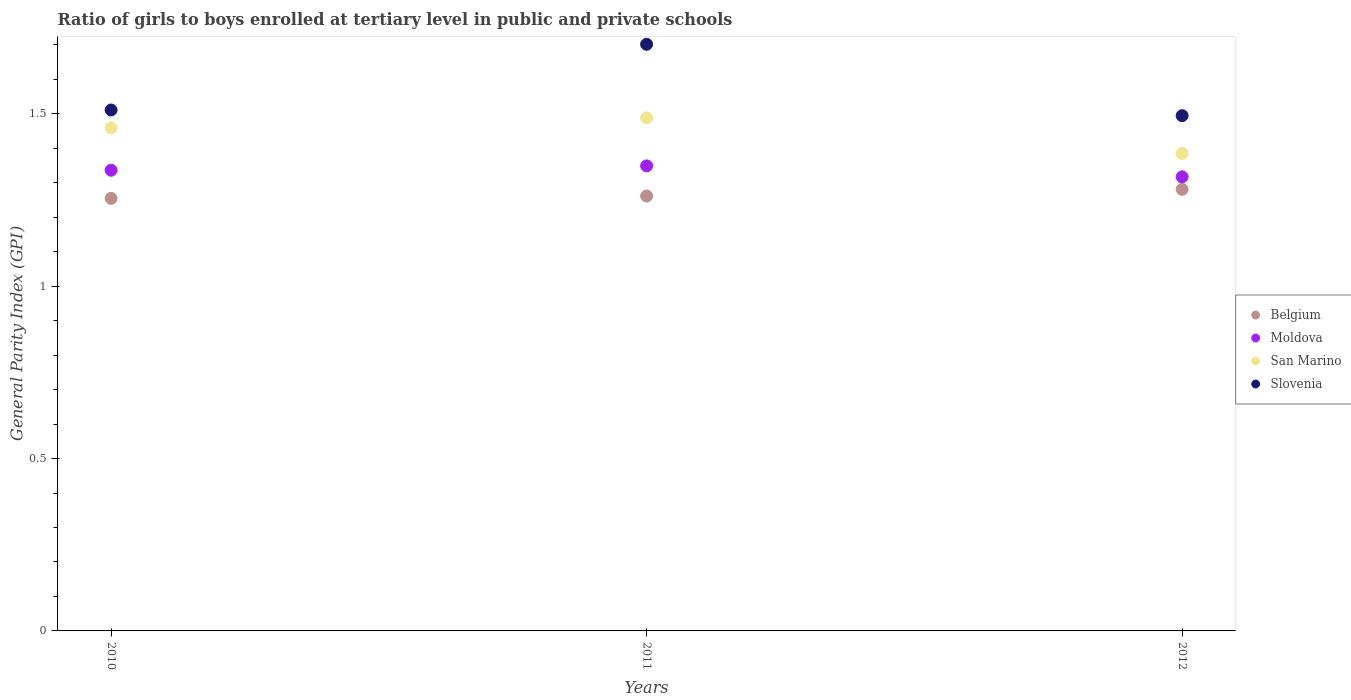How many different coloured dotlines are there?
Offer a very short reply. 4. What is the general parity index in Belgium in 2010?
Your answer should be very brief. 1.25. Across all years, what is the maximum general parity index in Belgium?
Make the answer very short. 1.28. Across all years, what is the minimum general parity index in San Marino?
Offer a very short reply. 1.38. In which year was the general parity index in Belgium maximum?
Provide a succinct answer. 2012. What is the total general parity index in Slovenia in the graph?
Provide a short and direct response. 4.71. What is the difference between the general parity index in Slovenia in 2011 and that in 2012?
Give a very brief answer. 0.21. What is the difference between the general parity index in Moldova in 2011 and the general parity index in Slovenia in 2012?
Your answer should be very brief. -0.15. What is the average general parity index in Slovenia per year?
Make the answer very short. 1.57. In the year 2011, what is the difference between the general parity index in Slovenia and general parity index in Belgium?
Your answer should be very brief. 0.44. What is the ratio of the general parity index in San Marino in 2010 to that in 2011?
Keep it short and to the point. 0.98. Is the general parity index in Slovenia in 2010 less than that in 2012?
Make the answer very short. No. What is the difference between the highest and the second highest general parity index in Slovenia?
Offer a terse response. 0.19. What is the difference between the highest and the lowest general parity index in Moldova?
Make the answer very short. 0.03. In how many years, is the general parity index in Slovenia greater than the average general parity index in Slovenia taken over all years?
Provide a succinct answer. 1. Is the sum of the general parity index in Belgium in 2010 and 2011 greater than the maximum general parity index in Moldova across all years?
Ensure brevity in your answer.  Yes. Is it the case that in every year, the sum of the general parity index in Moldova and general parity index in Belgium  is greater than the sum of general parity index in Slovenia and general parity index in San Marino?
Your answer should be very brief. Yes. Is it the case that in every year, the sum of the general parity index in San Marino and general parity index in Belgium  is greater than the general parity index in Slovenia?
Ensure brevity in your answer.  Yes. Does the general parity index in San Marino monotonically increase over the years?
Make the answer very short. No. Does the graph contain grids?
Your answer should be compact. No. Where does the legend appear in the graph?
Provide a short and direct response. Center right. What is the title of the graph?
Offer a terse response. Ratio of girls to boys enrolled at tertiary level in public and private schools. Does "Lesotho" appear as one of the legend labels in the graph?
Keep it short and to the point. No. What is the label or title of the X-axis?
Give a very brief answer. Years. What is the label or title of the Y-axis?
Ensure brevity in your answer.  General Parity Index (GPI). What is the General Parity Index (GPI) in Belgium in 2010?
Your response must be concise. 1.25. What is the General Parity Index (GPI) of Moldova in 2010?
Provide a short and direct response. 1.34. What is the General Parity Index (GPI) of San Marino in 2010?
Your response must be concise. 1.46. What is the General Parity Index (GPI) in Slovenia in 2010?
Make the answer very short. 1.51. What is the General Parity Index (GPI) in Belgium in 2011?
Offer a very short reply. 1.26. What is the General Parity Index (GPI) of Moldova in 2011?
Your response must be concise. 1.35. What is the General Parity Index (GPI) in San Marino in 2011?
Your answer should be very brief. 1.49. What is the General Parity Index (GPI) of Slovenia in 2011?
Provide a succinct answer. 1.7. What is the General Parity Index (GPI) in Belgium in 2012?
Offer a very short reply. 1.28. What is the General Parity Index (GPI) in Moldova in 2012?
Give a very brief answer. 1.32. What is the General Parity Index (GPI) in San Marino in 2012?
Make the answer very short. 1.38. What is the General Parity Index (GPI) in Slovenia in 2012?
Make the answer very short. 1.49. Across all years, what is the maximum General Parity Index (GPI) of Belgium?
Provide a short and direct response. 1.28. Across all years, what is the maximum General Parity Index (GPI) in Moldova?
Give a very brief answer. 1.35. Across all years, what is the maximum General Parity Index (GPI) in San Marino?
Your response must be concise. 1.49. Across all years, what is the maximum General Parity Index (GPI) in Slovenia?
Provide a short and direct response. 1.7. Across all years, what is the minimum General Parity Index (GPI) of Belgium?
Your response must be concise. 1.25. Across all years, what is the minimum General Parity Index (GPI) of Moldova?
Offer a very short reply. 1.32. Across all years, what is the minimum General Parity Index (GPI) of San Marino?
Your response must be concise. 1.38. Across all years, what is the minimum General Parity Index (GPI) of Slovenia?
Offer a very short reply. 1.49. What is the total General Parity Index (GPI) in Belgium in the graph?
Ensure brevity in your answer.  3.8. What is the total General Parity Index (GPI) in Moldova in the graph?
Your answer should be very brief. 4. What is the total General Parity Index (GPI) of San Marino in the graph?
Provide a succinct answer. 4.33. What is the total General Parity Index (GPI) of Slovenia in the graph?
Provide a succinct answer. 4.71. What is the difference between the General Parity Index (GPI) in Belgium in 2010 and that in 2011?
Provide a succinct answer. -0.01. What is the difference between the General Parity Index (GPI) of Moldova in 2010 and that in 2011?
Your answer should be compact. -0.01. What is the difference between the General Parity Index (GPI) of San Marino in 2010 and that in 2011?
Ensure brevity in your answer.  -0.03. What is the difference between the General Parity Index (GPI) of Slovenia in 2010 and that in 2011?
Make the answer very short. -0.19. What is the difference between the General Parity Index (GPI) in Belgium in 2010 and that in 2012?
Keep it short and to the point. -0.03. What is the difference between the General Parity Index (GPI) in Moldova in 2010 and that in 2012?
Give a very brief answer. 0.02. What is the difference between the General Parity Index (GPI) in San Marino in 2010 and that in 2012?
Keep it short and to the point. 0.07. What is the difference between the General Parity Index (GPI) in Slovenia in 2010 and that in 2012?
Give a very brief answer. 0.02. What is the difference between the General Parity Index (GPI) in Belgium in 2011 and that in 2012?
Provide a succinct answer. -0.02. What is the difference between the General Parity Index (GPI) of Moldova in 2011 and that in 2012?
Keep it short and to the point. 0.03. What is the difference between the General Parity Index (GPI) of San Marino in 2011 and that in 2012?
Give a very brief answer. 0.1. What is the difference between the General Parity Index (GPI) of Slovenia in 2011 and that in 2012?
Keep it short and to the point. 0.21. What is the difference between the General Parity Index (GPI) in Belgium in 2010 and the General Parity Index (GPI) in Moldova in 2011?
Offer a terse response. -0.09. What is the difference between the General Parity Index (GPI) of Belgium in 2010 and the General Parity Index (GPI) of San Marino in 2011?
Ensure brevity in your answer.  -0.23. What is the difference between the General Parity Index (GPI) in Belgium in 2010 and the General Parity Index (GPI) in Slovenia in 2011?
Offer a terse response. -0.45. What is the difference between the General Parity Index (GPI) of Moldova in 2010 and the General Parity Index (GPI) of San Marino in 2011?
Keep it short and to the point. -0.15. What is the difference between the General Parity Index (GPI) of Moldova in 2010 and the General Parity Index (GPI) of Slovenia in 2011?
Offer a very short reply. -0.37. What is the difference between the General Parity Index (GPI) of San Marino in 2010 and the General Parity Index (GPI) of Slovenia in 2011?
Offer a terse response. -0.24. What is the difference between the General Parity Index (GPI) in Belgium in 2010 and the General Parity Index (GPI) in Moldova in 2012?
Ensure brevity in your answer.  -0.06. What is the difference between the General Parity Index (GPI) in Belgium in 2010 and the General Parity Index (GPI) in San Marino in 2012?
Offer a terse response. -0.13. What is the difference between the General Parity Index (GPI) of Belgium in 2010 and the General Parity Index (GPI) of Slovenia in 2012?
Ensure brevity in your answer.  -0.24. What is the difference between the General Parity Index (GPI) in Moldova in 2010 and the General Parity Index (GPI) in San Marino in 2012?
Provide a succinct answer. -0.05. What is the difference between the General Parity Index (GPI) in Moldova in 2010 and the General Parity Index (GPI) in Slovenia in 2012?
Provide a short and direct response. -0.16. What is the difference between the General Parity Index (GPI) in San Marino in 2010 and the General Parity Index (GPI) in Slovenia in 2012?
Make the answer very short. -0.04. What is the difference between the General Parity Index (GPI) of Belgium in 2011 and the General Parity Index (GPI) of Moldova in 2012?
Your answer should be very brief. -0.06. What is the difference between the General Parity Index (GPI) in Belgium in 2011 and the General Parity Index (GPI) in San Marino in 2012?
Make the answer very short. -0.12. What is the difference between the General Parity Index (GPI) in Belgium in 2011 and the General Parity Index (GPI) in Slovenia in 2012?
Your answer should be very brief. -0.23. What is the difference between the General Parity Index (GPI) in Moldova in 2011 and the General Parity Index (GPI) in San Marino in 2012?
Your answer should be compact. -0.04. What is the difference between the General Parity Index (GPI) of Moldova in 2011 and the General Parity Index (GPI) of Slovenia in 2012?
Keep it short and to the point. -0.15. What is the difference between the General Parity Index (GPI) in San Marino in 2011 and the General Parity Index (GPI) in Slovenia in 2012?
Your answer should be compact. -0.01. What is the average General Parity Index (GPI) of Belgium per year?
Provide a short and direct response. 1.27. What is the average General Parity Index (GPI) in Moldova per year?
Provide a succinct answer. 1.33. What is the average General Parity Index (GPI) of San Marino per year?
Give a very brief answer. 1.44. What is the average General Parity Index (GPI) of Slovenia per year?
Offer a very short reply. 1.57. In the year 2010, what is the difference between the General Parity Index (GPI) of Belgium and General Parity Index (GPI) of Moldova?
Your answer should be very brief. -0.08. In the year 2010, what is the difference between the General Parity Index (GPI) of Belgium and General Parity Index (GPI) of San Marino?
Make the answer very short. -0.2. In the year 2010, what is the difference between the General Parity Index (GPI) of Belgium and General Parity Index (GPI) of Slovenia?
Offer a very short reply. -0.26. In the year 2010, what is the difference between the General Parity Index (GPI) of Moldova and General Parity Index (GPI) of San Marino?
Offer a terse response. -0.12. In the year 2010, what is the difference between the General Parity Index (GPI) of Moldova and General Parity Index (GPI) of Slovenia?
Provide a succinct answer. -0.17. In the year 2010, what is the difference between the General Parity Index (GPI) of San Marino and General Parity Index (GPI) of Slovenia?
Offer a terse response. -0.05. In the year 2011, what is the difference between the General Parity Index (GPI) in Belgium and General Parity Index (GPI) in Moldova?
Your answer should be compact. -0.09. In the year 2011, what is the difference between the General Parity Index (GPI) of Belgium and General Parity Index (GPI) of San Marino?
Provide a succinct answer. -0.23. In the year 2011, what is the difference between the General Parity Index (GPI) of Belgium and General Parity Index (GPI) of Slovenia?
Your response must be concise. -0.44. In the year 2011, what is the difference between the General Parity Index (GPI) in Moldova and General Parity Index (GPI) in San Marino?
Keep it short and to the point. -0.14. In the year 2011, what is the difference between the General Parity Index (GPI) of Moldova and General Parity Index (GPI) of Slovenia?
Give a very brief answer. -0.35. In the year 2011, what is the difference between the General Parity Index (GPI) of San Marino and General Parity Index (GPI) of Slovenia?
Your answer should be compact. -0.21. In the year 2012, what is the difference between the General Parity Index (GPI) in Belgium and General Parity Index (GPI) in Moldova?
Ensure brevity in your answer.  -0.04. In the year 2012, what is the difference between the General Parity Index (GPI) in Belgium and General Parity Index (GPI) in San Marino?
Your answer should be compact. -0.1. In the year 2012, what is the difference between the General Parity Index (GPI) of Belgium and General Parity Index (GPI) of Slovenia?
Keep it short and to the point. -0.21. In the year 2012, what is the difference between the General Parity Index (GPI) of Moldova and General Parity Index (GPI) of San Marino?
Offer a terse response. -0.07. In the year 2012, what is the difference between the General Parity Index (GPI) of Moldova and General Parity Index (GPI) of Slovenia?
Offer a very short reply. -0.18. In the year 2012, what is the difference between the General Parity Index (GPI) of San Marino and General Parity Index (GPI) of Slovenia?
Your response must be concise. -0.11. What is the ratio of the General Parity Index (GPI) of Moldova in 2010 to that in 2011?
Your answer should be compact. 0.99. What is the ratio of the General Parity Index (GPI) of San Marino in 2010 to that in 2011?
Your answer should be compact. 0.98. What is the ratio of the General Parity Index (GPI) of Slovenia in 2010 to that in 2011?
Give a very brief answer. 0.89. What is the ratio of the General Parity Index (GPI) in Belgium in 2010 to that in 2012?
Offer a terse response. 0.98. What is the ratio of the General Parity Index (GPI) in Moldova in 2010 to that in 2012?
Your answer should be very brief. 1.01. What is the ratio of the General Parity Index (GPI) of San Marino in 2010 to that in 2012?
Provide a short and direct response. 1.05. What is the ratio of the General Parity Index (GPI) in Slovenia in 2010 to that in 2012?
Your answer should be very brief. 1.01. What is the ratio of the General Parity Index (GPI) in Belgium in 2011 to that in 2012?
Your response must be concise. 0.98. What is the ratio of the General Parity Index (GPI) in Moldova in 2011 to that in 2012?
Offer a very short reply. 1.02. What is the ratio of the General Parity Index (GPI) of San Marino in 2011 to that in 2012?
Your answer should be very brief. 1.07. What is the ratio of the General Parity Index (GPI) of Slovenia in 2011 to that in 2012?
Give a very brief answer. 1.14. What is the difference between the highest and the second highest General Parity Index (GPI) in Belgium?
Give a very brief answer. 0.02. What is the difference between the highest and the second highest General Parity Index (GPI) in Moldova?
Offer a terse response. 0.01. What is the difference between the highest and the second highest General Parity Index (GPI) of San Marino?
Your answer should be very brief. 0.03. What is the difference between the highest and the second highest General Parity Index (GPI) of Slovenia?
Ensure brevity in your answer.  0.19. What is the difference between the highest and the lowest General Parity Index (GPI) of Belgium?
Make the answer very short. 0.03. What is the difference between the highest and the lowest General Parity Index (GPI) of Moldova?
Your answer should be compact. 0.03. What is the difference between the highest and the lowest General Parity Index (GPI) of San Marino?
Provide a succinct answer. 0.1. What is the difference between the highest and the lowest General Parity Index (GPI) of Slovenia?
Your answer should be very brief. 0.21. 